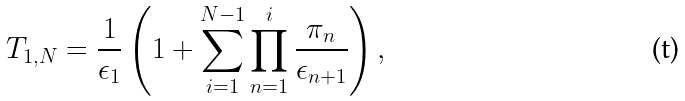Convert formula to latex. <formula><loc_0><loc_0><loc_500><loc_500>T _ { 1 , N } = \frac { 1 } { \epsilon _ { 1 } } \left ( 1 + \sum _ { i = 1 } ^ { N - 1 } \prod _ { n = 1 } ^ { i } \frac { \pi _ { n } } { \epsilon _ { n + 1 } } \right ) ,</formula> 